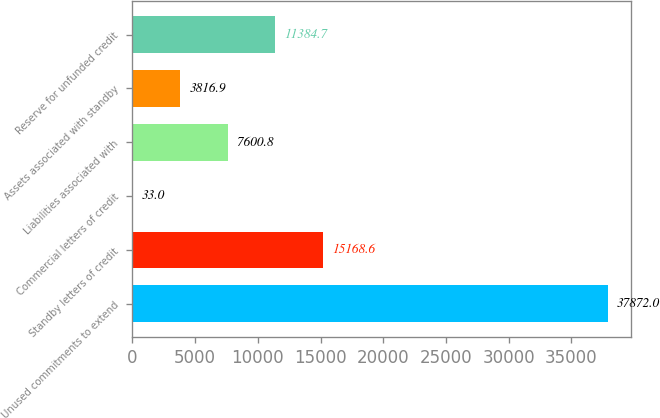Convert chart. <chart><loc_0><loc_0><loc_500><loc_500><bar_chart><fcel>Unused commitments to extend<fcel>Standby letters of credit<fcel>Commercial letters of credit<fcel>Liabilities associated with<fcel>Assets associated with standby<fcel>Reserve for unfunded credit<nl><fcel>37872<fcel>15168.6<fcel>33<fcel>7600.8<fcel>3816.9<fcel>11384.7<nl></chart> 